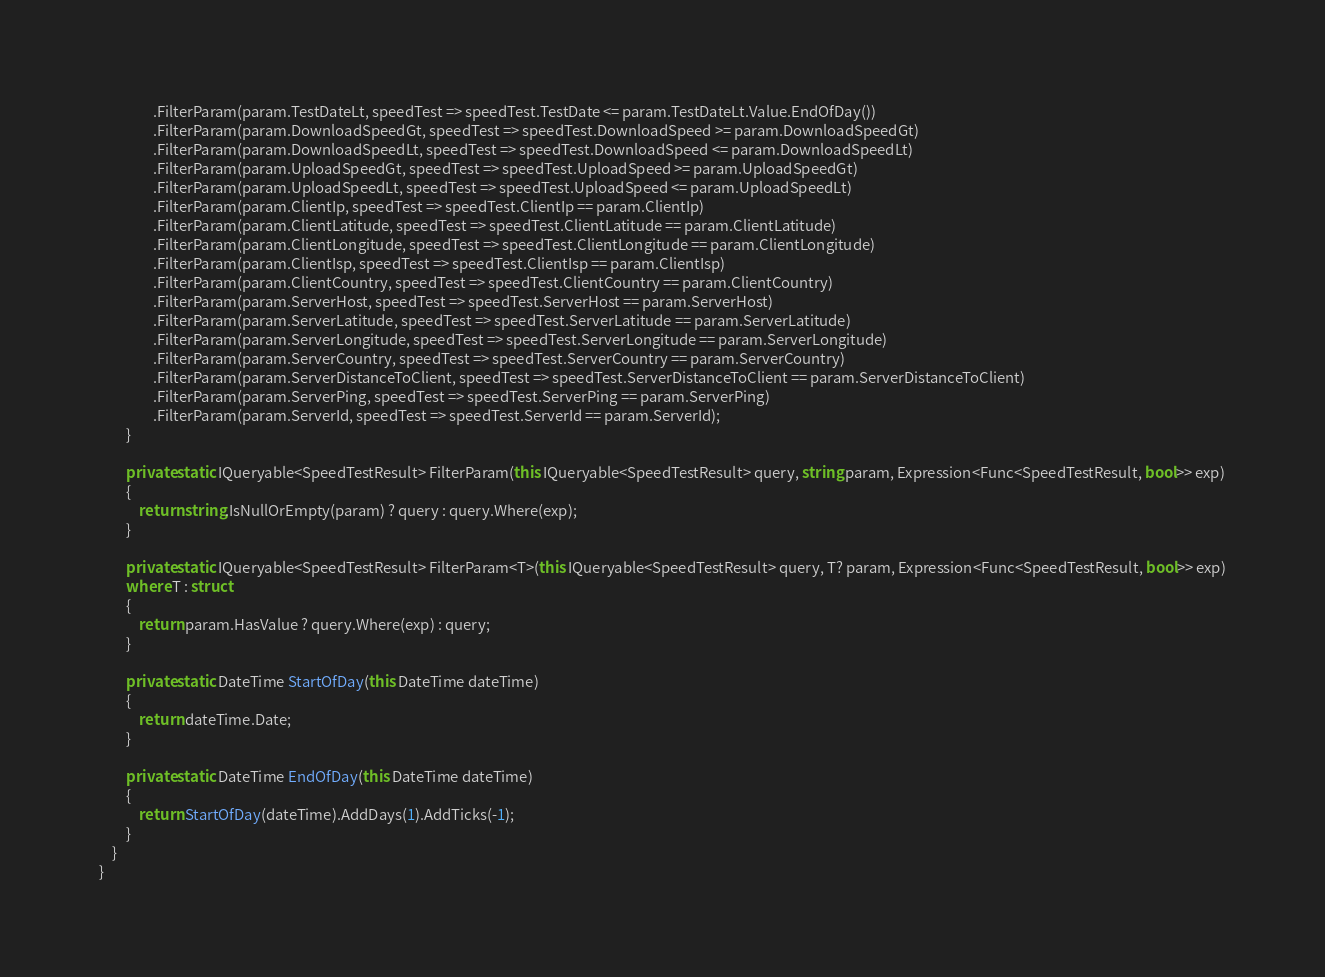Convert code to text. <code><loc_0><loc_0><loc_500><loc_500><_C#_>                .FilterParam(param.TestDateLt, speedTest => speedTest.TestDate <= param.TestDateLt.Value.EndOfDay())
                .FilterParam(param.DownloadSpeedGt, speedTest => speedTest.DownloadSpeed >= param.DownloadSpeedGt)
                .FilterParam(param.DownloadSpeedLt, speedTest => speedTest.DownloadSpeed <= param.DownloadSpeedLt)
                .FilterParam(param.UploadSpeedGt, speedTest => speedTest.UploadSpeed >= param.UploadSpeedGt)
                .FilterParam(param.UploadSpeedLt, speedTest => speedTest.UploadSpeed <= param.UploadSpeedLt)
                .FilterParam(param.ClientIp, speedTest => speedTest.ClientIp == param.ClientIp)
                .FilterParam(param.ClientLatitude, speedTest => speedTest.ClientLatitude == param.ClientLatitude)
                .FilterParam(param.ClientLongitude, speedTest => speedTest.ClientLongitude == param.ClientLongitude)
                .FilterParam(param.ClientIsp, speedTest => speedTest.ClientIsp == param.ClientIsp)
                .FilterParam(param.ClientCountry, speedTest => speedTest.ClientCountry == param.ClientCountry)
                .FilterParam(param.ServerHost, speedTest => speedTest.ServerHost == param.ServerHost)
                .FilterParam(param.ServerLatitude, speedTest => speedTest.ServerLatitude == param.ServerLatitude)
                .FilterParam(param.ServerLongitude, speedTest => speedTest.ServerLongitude == param.ServerLongitude)
                .FilterParam(param.ServerCountry, speedTest => speedTest.ServerCountry == param.ServerCountry)
                .FilterParam(param.ServerDistanceToClient, speedTest => speedTest.ServerDistanceToClient == param.ServerDistanceToClient)
                .FilterParam(param.ServerPing, speedTest => speedTest.ServerPing == param.ServerPing)
                .FilterParam(param.ServerId, speedTest => speedTest.ServerId == param.ServerId);
        }

        private static IQueryable<SpeedTestResult> FilterParam(this IQueryable<SpeedTestResult> query, string param, Expression<Func<SpeedTestResult, bool>> exp)
        {
            return string.IsNullOrEmpty(param) ? query : query.Where(exp);
        }

        private static IQueryable<SpeedTestResult> FilterParam<T>(this IQueryable<SpeedTestResult> query, T? param, Expression<Func<SpeedTestResult, bool>> exp)
        where T : struct
        {
            return param.HasValue ? query.Where(exp) : query;
        }

        private static DateTime StartOfDay(this DateTime dateTime)
        {
            return dateTime.Date;
        }

        private static DateTime EndOfDay(this DateTime dateTime)
        {
            return StartOfDay(dateTime).AddDays(1).AddTicks(-1);
        }
    }
}</code> 